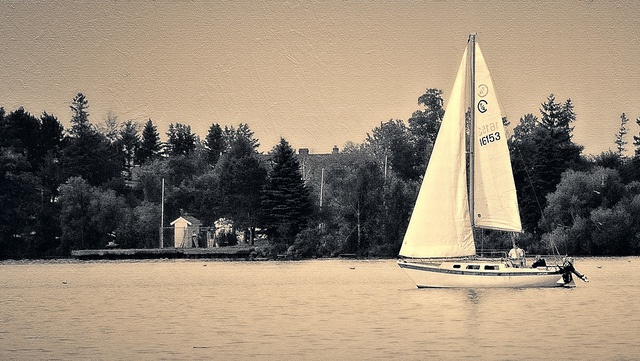Describe the objects in this image and their specific colors. I can see boat in gray, beige, lightyellow, and darkgray tones, people in gray, black, darkgray, and ivory tones, people in gray, darkgray, beige, and tan tones, and people in gray, black, darkgray, and white tones in this image. 